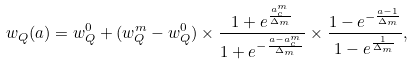Convert formula to latex. <formula><loc_0><loc_0><loc_500><loc_500>w _ { Q } ( a ) = w ^ { 0 } _ { Q } + ( w ^ { m } _ { Q } - w ^ { 0 } _ { Q } ) \times \frac { 1 + e ^ { \frac { a ^ { m } _ { c } } { \Delta _ { m } } } } { 1 + e ^ { - \frac { a - a ^ { m } _ { c } } { \Delta _ { m } } } } \times \frac { 1 - e ^ { - \frac { a - 1 } { \Delta _ { m } } } } { 1 - e ^ { \frac { 1 } { \Delta _ { m } } } } ,</formula> 